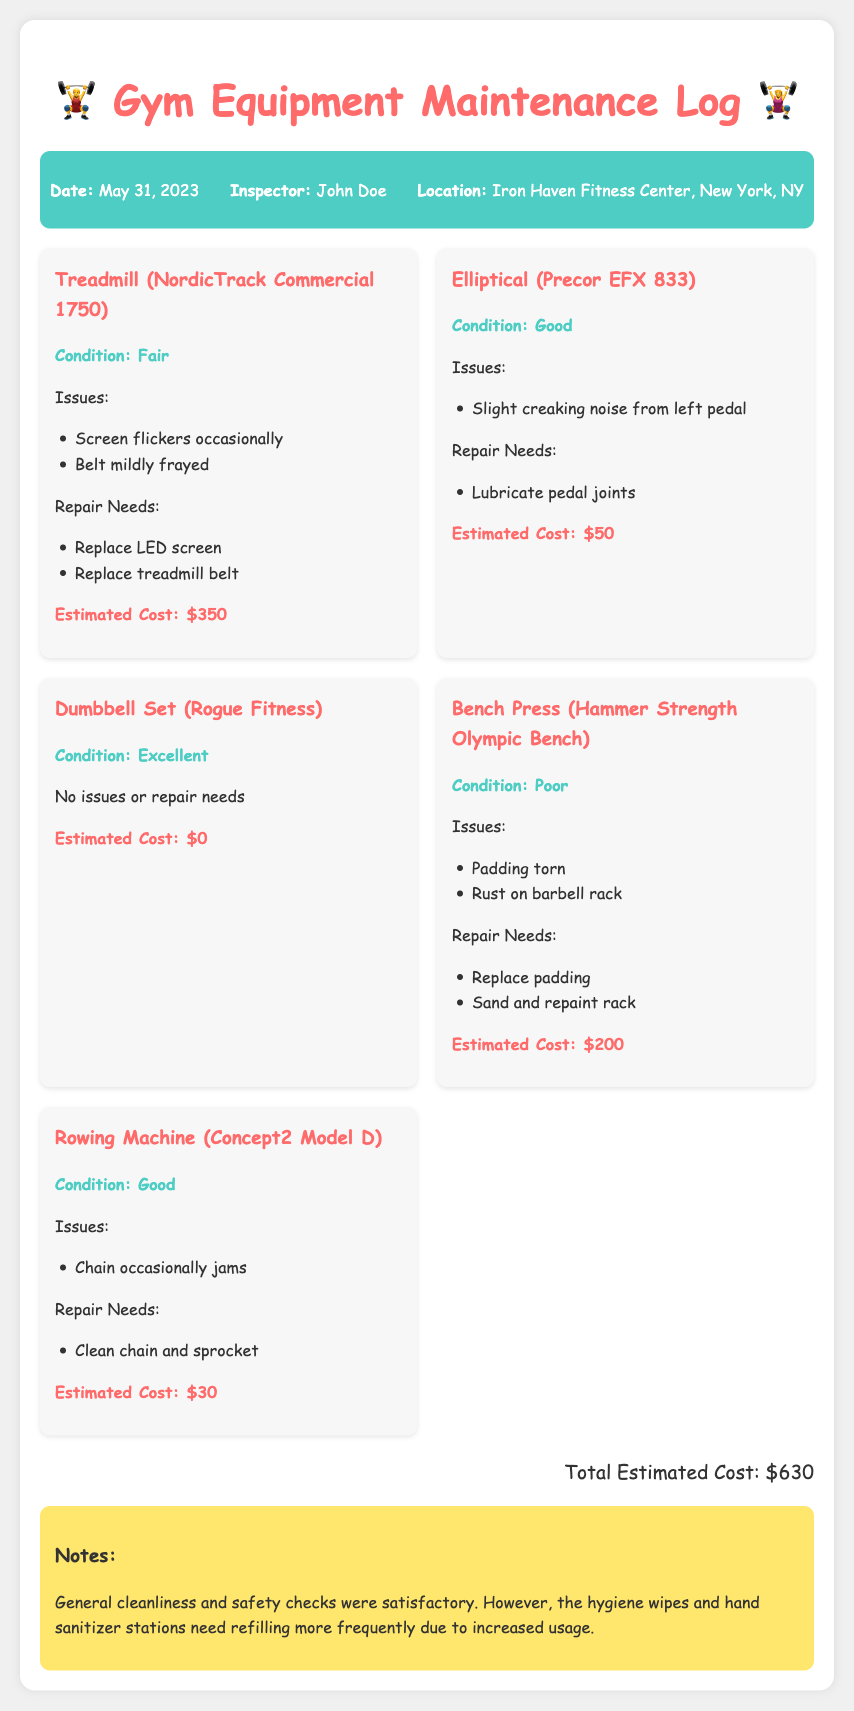What is the date of the inspection? The date of the inspection is provided in the header info section as May 31, 2023.
Answer: May 31, 2023 Who conducted the inspection? The inspector's name is mentioned in the header info section as John Doe.
Answer: John Doe What is the total estimated cost for repairs? The total estimated cost is calculated at the bottom of the document, summing all individual costs, which is $630.
Answer: $630 How is the condition of the Dumbbell Set? The condition of the Dumbbell Set is noted in its description as Excellent.
Answer: Excellent What issues are reported for the Treadmill? The issues listed under the Treadmill are that the screen flickers occasionally and the belt is mildly frayed.
Answer: Screen flickers occasionally; Belt mildly frayed What repairs are needed for the Bench Press? The required repairs for the Bench Press include replacing the padding and sanding and repainting the rack.
Answer: Replace padding; Sand and repaint rack What was the general safety check result? The maintenance log notes that general cleanliness and safety checks were satisfactory, indicating a positive outcome.
Answer: Satisfactory What equipment has no issues or repair needs? The equipment that reports no issues or repair needs is the Dumbbell Set from Rogue Fitness.
Answer: Dumbbell Set (Rogue Fitness) How often does the hygiene supplies need refilling? The notes state that the hygiene wipes and hand sanitizer stations need refilling more frequently due to increased usage.
Answer: More frequently 